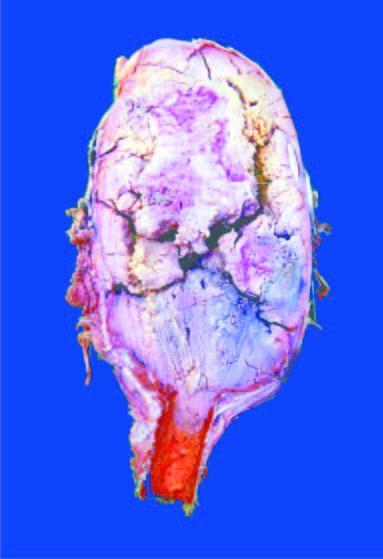what is the end of the long bone expanded in?
Answer the question using a single word or phrase. Region of epiphysis 